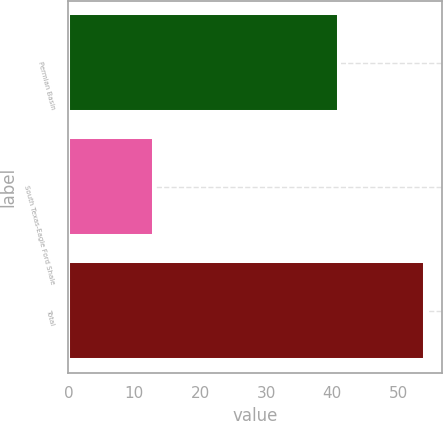Convert chart. <chart><loc_0><loc_0><loc_500><loc_500><bar_chart><fcel>Permian Basin<fcel>South Texas-Eagle Ford Shale<fcel>Total<nl><fcel>41<fcel>13<fcel>54<nl></chart> 